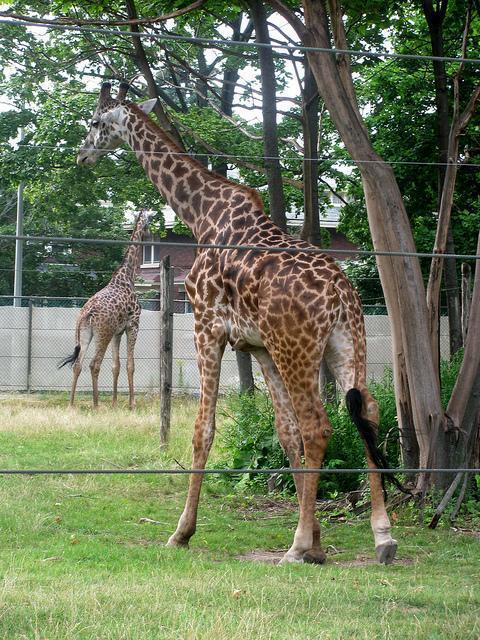How many giraffes are there?
Give a very brief answer. 2. How many giraffes can be seen?
Give a very brief answer. 2. How many people are wearing hats?
Give a very brief answer. 0. 